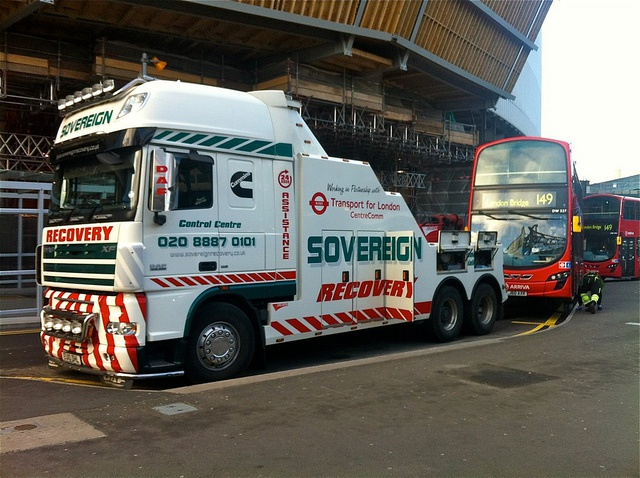Describe the objects in this image and their specific colors. I can see truck in black, darkgray, ivory, and gray tones, bus in black, darkgray, and gray tones, bus in black, darkblue, maroon, and blue tones, and people in black, gray, and darkgreen tones in this image. 